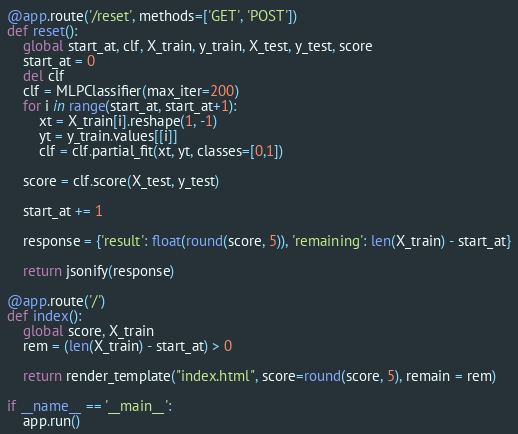Convert code to text. <code><loc_0><loc_0><loc_500><loc_500><_Python_>
@app.route('/reset', methods=['GET', 'POST'])
def reset():
    global start_at, clf, X_train, y_train, X_test, y_test, score
    start_at = 0
    del clf
    clf = MLPClassifier(max_iter=200)
    for i in range(start_at, start_at+1):
        xt = X_train[i].reshape(1, -1)
        yt = y_train.values[[i]]
        clf = clf.partial_fit(xt, yt, classes=[0,1])

    score = clf.score(X_test, y_test)

    start_at += 1

    response = {'result': float(round(score, 5)), 'remaining': len(X_train) - start_at}

    return jsonify(response)

@app.route('/')
def index():
    global score, X_train
    rem = (len(X_train) - start_at) > 0

    return render_template("index.html", score=round(score, 5), remain = rem)

if __name__ == '__main__':
    app.run()</code> 